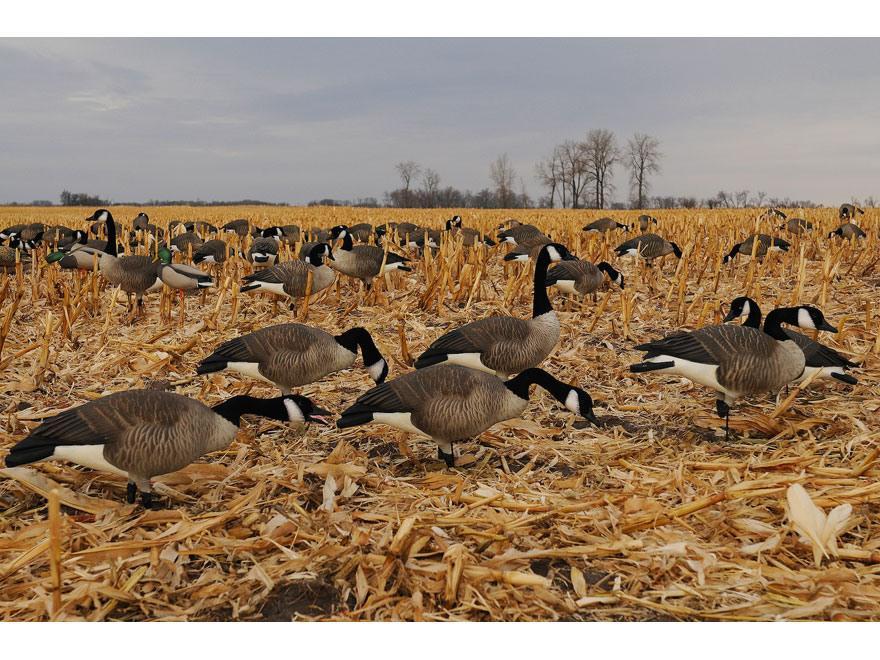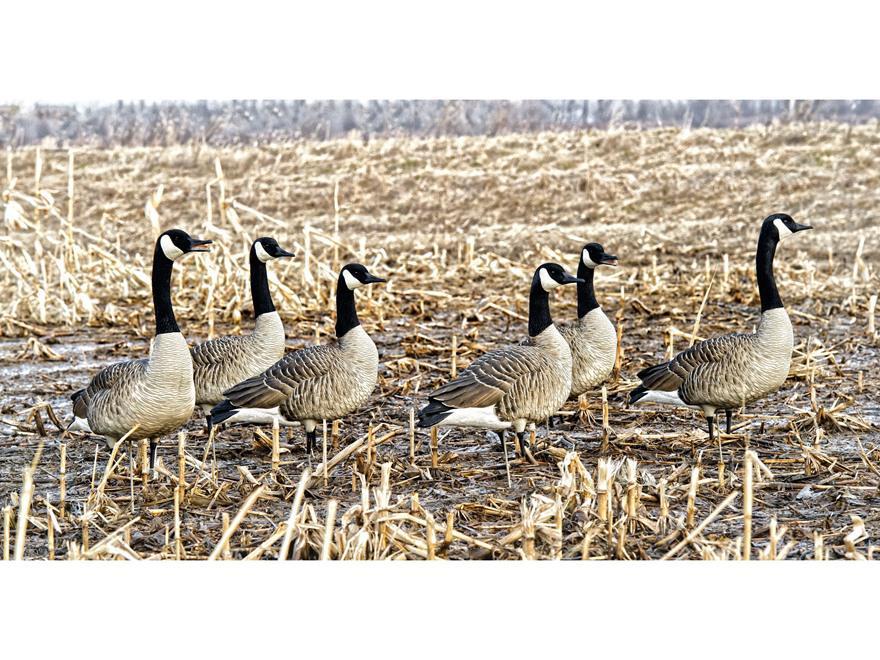The first image is the image on the left, the second image is the image on the right. Analyze the images presented: Is the assertion "There are 18 or more Canadian Geese in open fields." valid? Answer yes or no. Yes. 